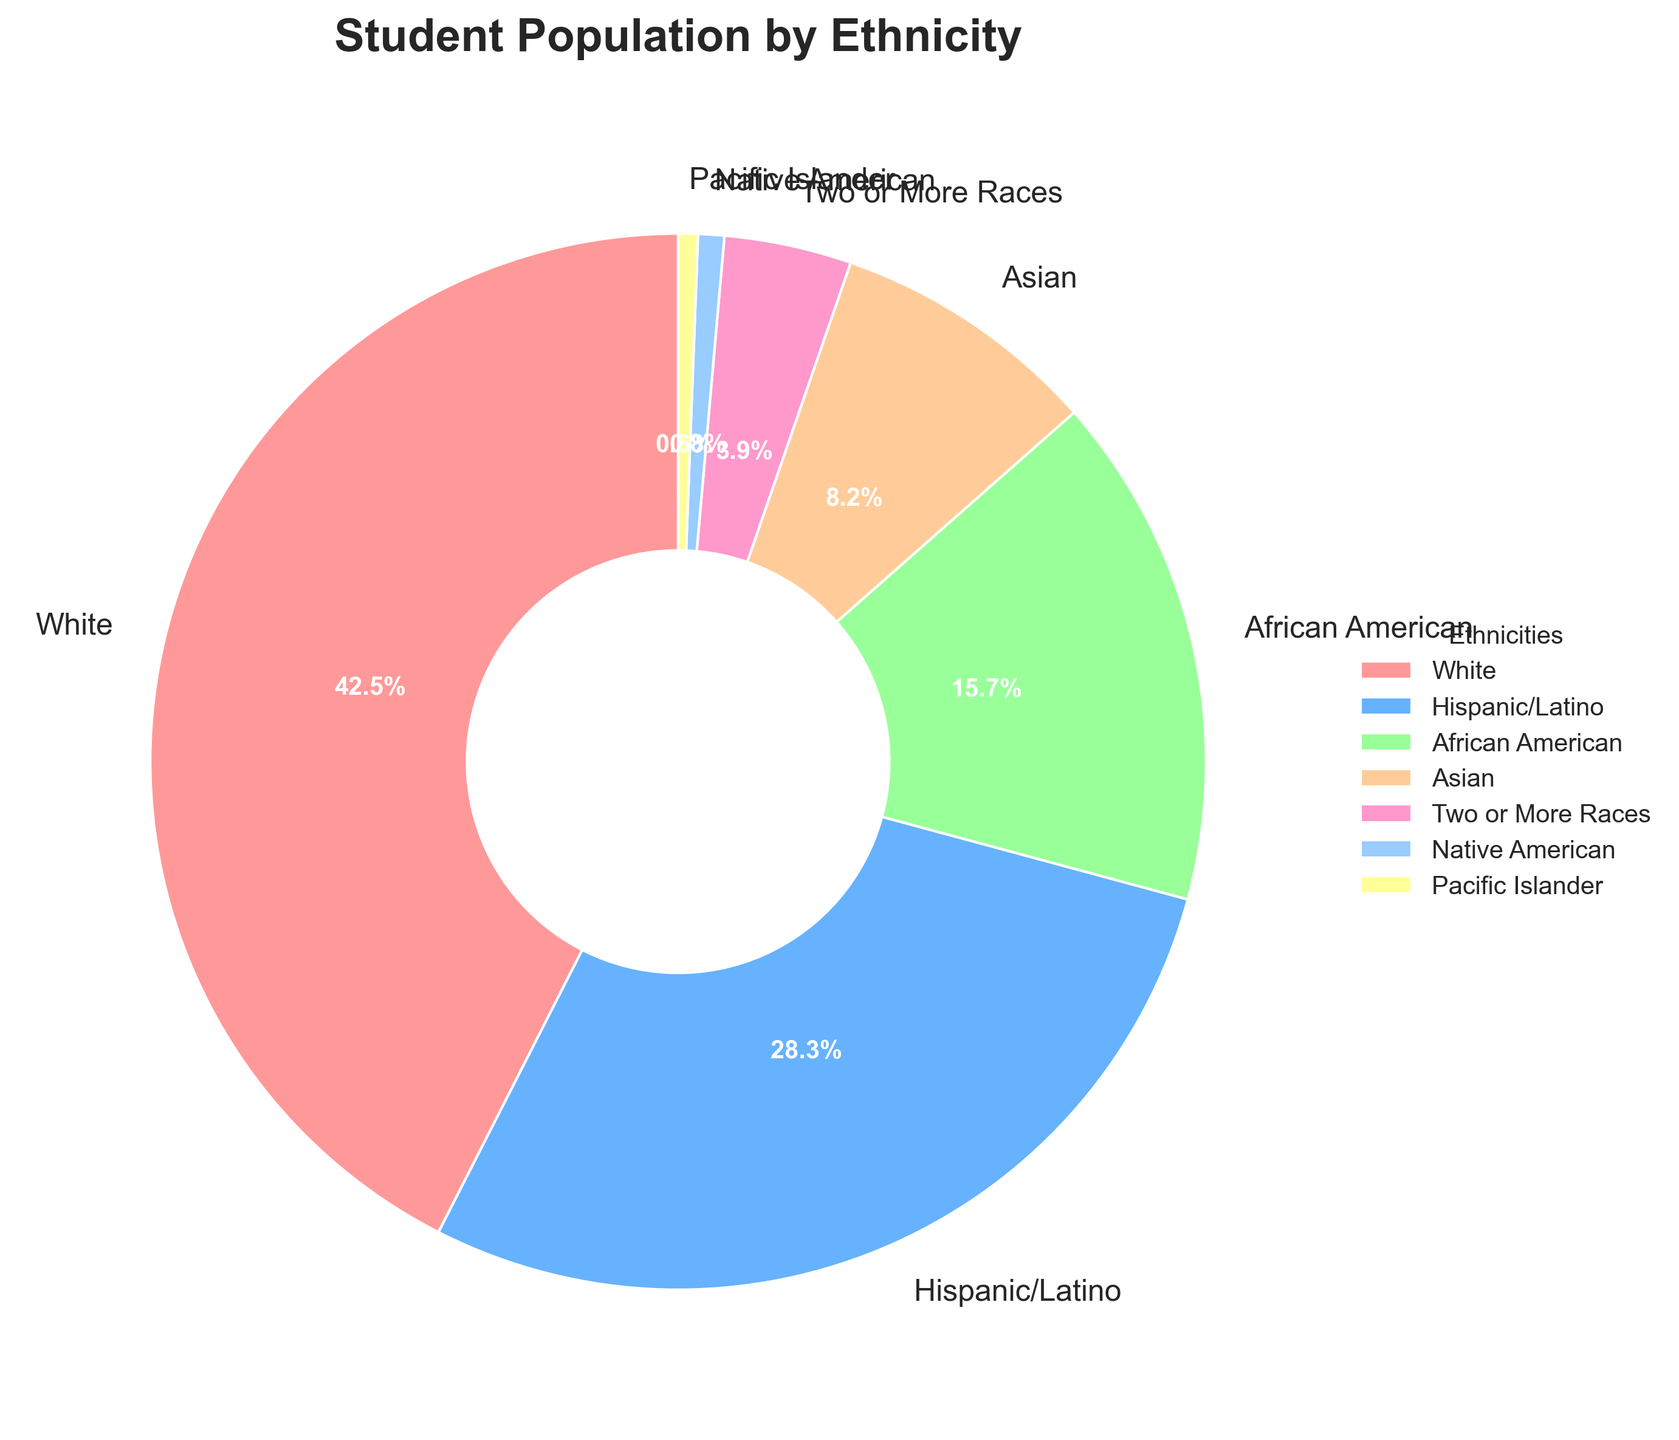What percentage of the student population is either African American or Asian? Sum the percentages for African American (15.7%) and Asian (8.2%): 15.7 + 8.2 = 23.9%
Answer: 23.9% Which ethnicity has the highest representation in the student population? The pie chart shows that White students have the largest segment, representing 42.5% of the student population.
Answer: White Are there more Hispanic/Latino students or students of Two or More Races? Compare the percentages: Hispanic/Latino (28.3%) and Two or More Races (3.9%). 28.3% is greater than 3.9%.
Answer: Hispanic/Latino What is the combined percentage of Native American and Pacific Islander students? Add the percentages for Native American (0.8%) and Pacific Islander (0.6%): 0.8 + 0.6 = 1.4%
Answer: 1.4% Which ethnic group has nearly half the percentage of the White student population? Calculate half of 42.5%: 42.5 / 2 = 21.25%. Compare with other percentages. Hispanic/Latino (28.3%) is the closest but not quite, African American (15.7%) is closest to the half mark.
Answer: African American Is the percentage of Hispanic/Latino students higher than the combined percentage of Asian and students of Two or More Races? Compare Hispanic/Latino (28.3%) with the sum of Asian (8.2%) and Two or More Races (3.9%): 8.2 + 3.9 = 12.1%. 28.3% is greater than 12.1%.
Answer: Yes What is the second-largest ethnic group in terms of student population? The pie chart shows that Hispanic/Latino is the second-largest group with 28.3%.
Answer: Hispanic/Latino Which ethnicities represent less than 5% of the student population each? Identify the segments representing less than 5%: Two or More Races (3.9%), Native American (0.8%), and Pacific Islander (0.6%).
Answer: Two or More Races, Native American, Pacific Islander What is the total percentage of students from White, African American, and Native American ethnicities? Add the percentages of White (42.5%), African American (15.7%), and Native American (0.8%): 42.5 + 15.7 + 0.8 = 59%
Answer: 59% 